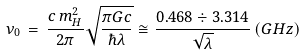Convert formula to latex. <formula><loc_0><loc_0><loc_500><loc_500>\nu _ { 0 } \, = \, \frac { c \, m _ { H } ^ { 2 } } { 2 \pi } \sqrt { \frac { \pi G c } { \hbar { \lambda } } } \cong \frac { 0 . 4 6 8 \div 3 . 3 1 4 } { \sqrt { \lambda } } \, ( G H z )</formula> 